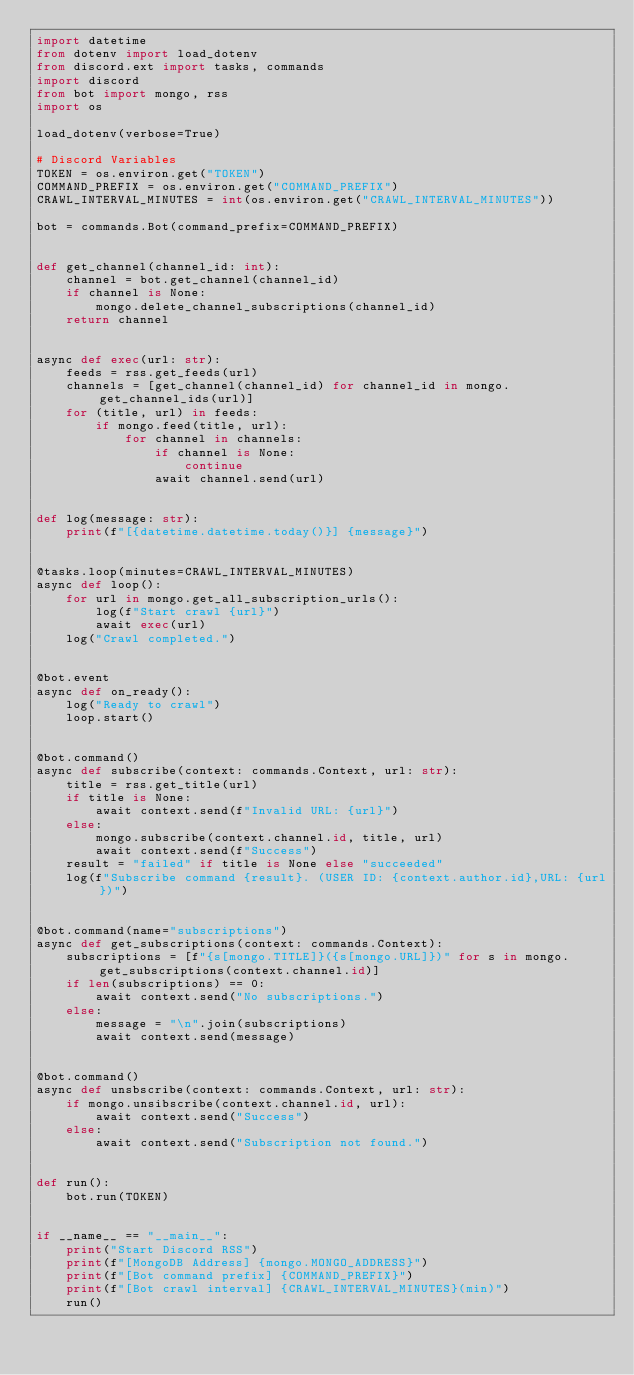<code> <loc_0><loc_0><loc_500><loc_500><_Python_>import datetime
from dotenv import load_dotenv
from discord.ext import tasks, commands
import discord
from bot import mongo, rss
import os

load_dotenv(verbose=True)

# Discord Variables
TOKEN = os.environ.get("TOKEN")
COMMAND_PREFIX = os.environ.get("COMMAND_PREFIX")
CRAWL_INTERVAL_MINUTES = int(os.environ.get("CRAWL_INTERVAL_MINUTES"))

bot = commands.Bot(command_prefix=COMMAND_PREFIX)


def get_channel(channel_id: int):
    channel = bot.get_channel(channel_id)
    if channel is None:
        mongo.delete_channel_subscriptions(channel_id)
    return channel


async def exec(url: str):
    feeds = rss.get_feeds(url)
    channels = [get_channel(channel_id) for channel_id in mongo.get_channel_ids(url)]
    for (title, url) in feeds:
        if mongo.feed(title, url):
            for channel in channels:
                if channel is None:
                    continue
                await channel.send(url)


def log(message: str):
    print(f"[{datetime.datetime.today()}] {message}")


@tasks.loop(minutes=CRAWL_INTERVAL_MINUTES)
async def loop():
    for url in mongo.get_all_subscription_urls():
        log(f"Start crawl {url}")
        await exec(url)
    log("Crawl completed.")


@bot.event
async def on_ready():
    log("Ready to crawl")
    loop.start()


@bot.command()
async def subscribe(context: commands.Context, url: str):
    title = rss.get_title(url)
    if title is None:
        await context.send(f"Invalid URL: {url}")
    else:
        mongo.subscribe(context.channel.id, title, url)
        await context.send(f"Success")
    result = "failed" if title is None else "succeeded"
    log(f"Subscribe command {result}. (USER ID: {context.author.id},URL: {url})")


@bot.command(name="subscriptions")
async def get_subscriptions(context: commands.Context):
    subscriptions = [f"{s[mongo.TITLE]}({s[mongo.URL]})" for s in mongo.get_subscriptions(context.channel.id)]
    if len(subscriptions) == 0:
        await context.send("No subscriptions.")
    else:
        message = "\n".join(subscriptions)
        await context.send(message)


@bot.command()
async def unsbscribe(context: commands.Context, url: str):
    if mongo.unsibscribe(context.channel.id, url):
        await context.send("Success")
    else:
        await context.send("Subscription not found.")


def run():
    bot.run(TOKEN)


if __name__ == "__main__":
    print("Start Discord RSS")
    print(f"[MongoDB Address] {mongo.MONGO_ADDRESS}")
    print(f"[Bot command prefix] {COMMAND_PREFIX}")
    print(f"[Bot crawl interval] {CRAWL_INTERVAL_MINUTES}(min)")
    run()</code> 